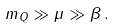Convert formula to latex. <formula><loc_0><loc_0><loc_500><loc_500>m _ { Q } \gg \mu \gg \beta \, .</formula> 